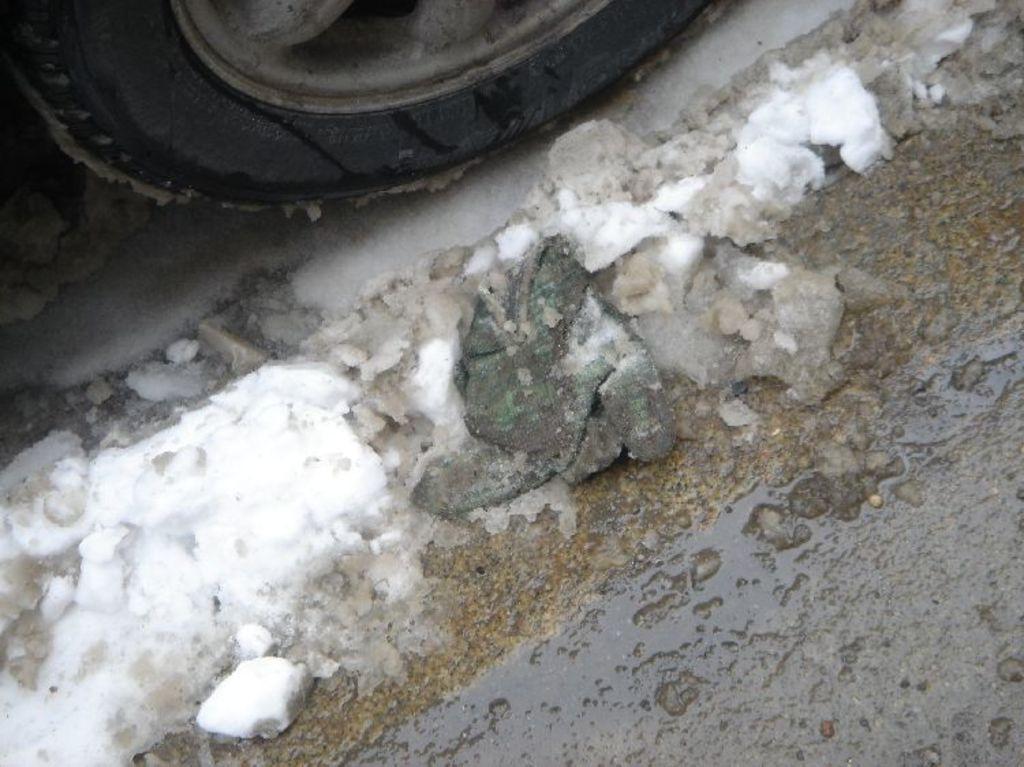Describe this image in one or two sentences. In this image we can see a vehicle tire and some snow on the road. 